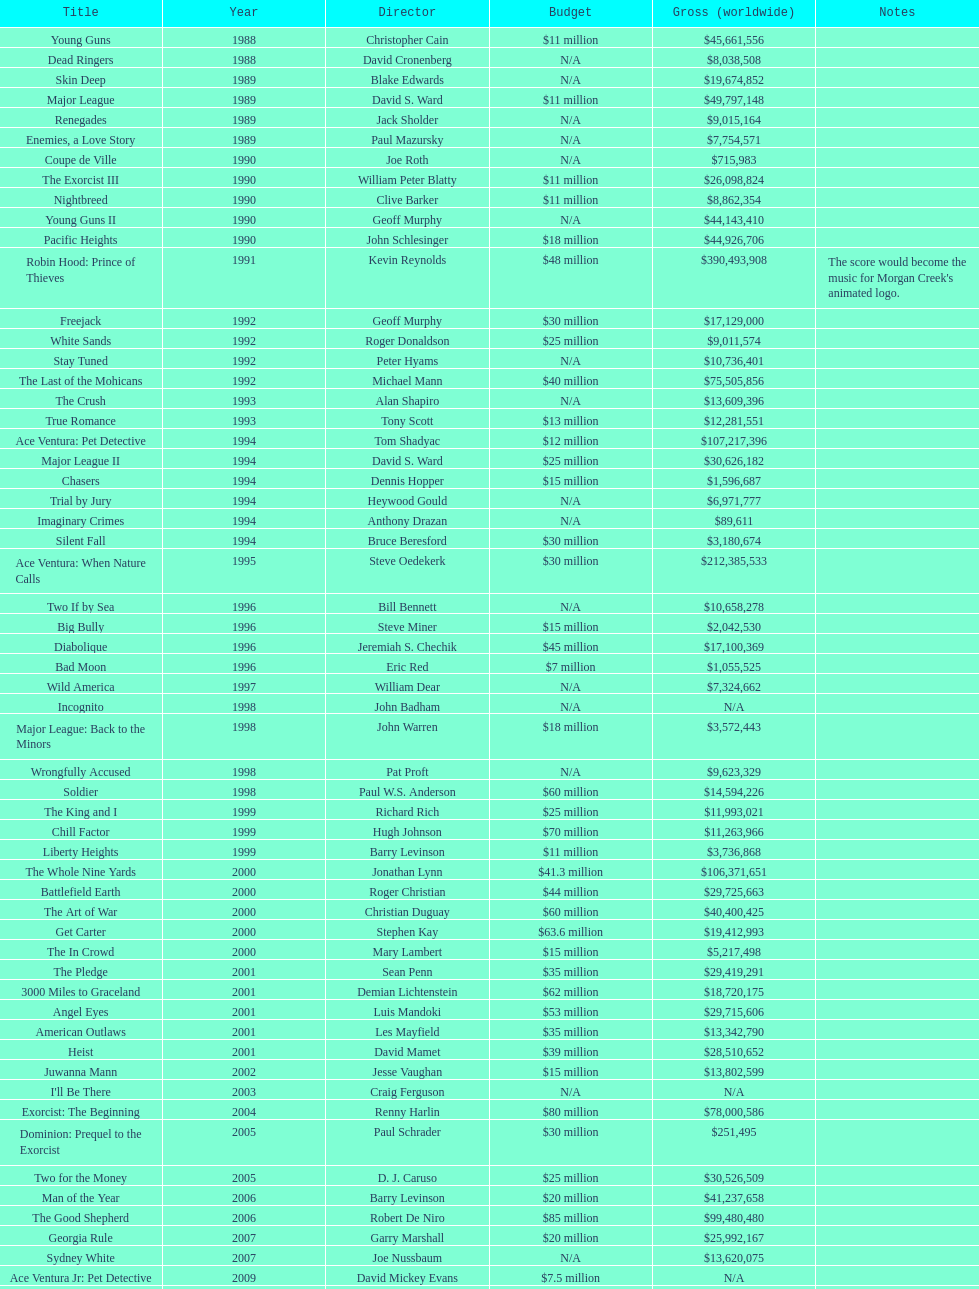Between ace ventura: when nature calls and major league: back to the minors, which movie had a larger budget? Ace Ventura: When Nature Calls. 